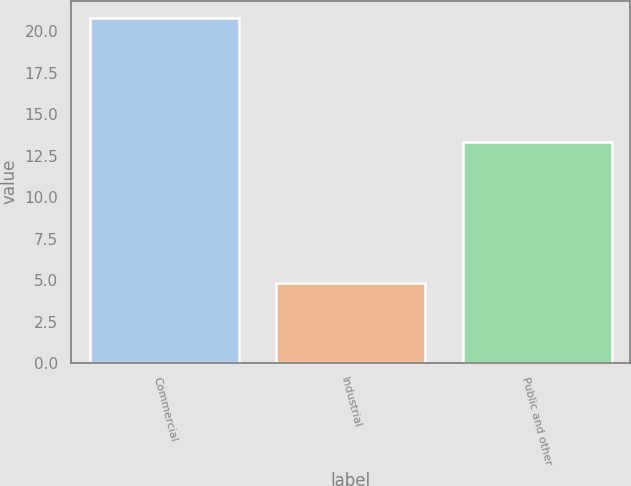Convert chart. <chart><loc_0><loc_0><loc_500><loc_500><bar_chart><fcel>Commercial<fcel>Industrial<fcel>Public and other<nl><fcel>20.8<fcel>4.8<fcel>13.3<nl></chart> 